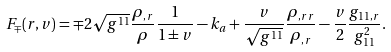<formula> <loc_0><loc_0><loc_500><loc_500>F _ { \mp } ( r , v ) = \mp 2 \sqrt { g ^ { 1 1 } } \frac { \rho _ { , r } } { \rho } \frac { 1 } { 1 \pm v } - k _ { a } + \frac { v } { \sqrt { g ^ { 1 1 } } } \frac { \rho _ { , r r } } { \rho _ { , r } } - \frac { v } { 2 } \frac { g _ { 1 1 , r } } { g _ { 1 1 } ^ { 2 } } .</formula> 